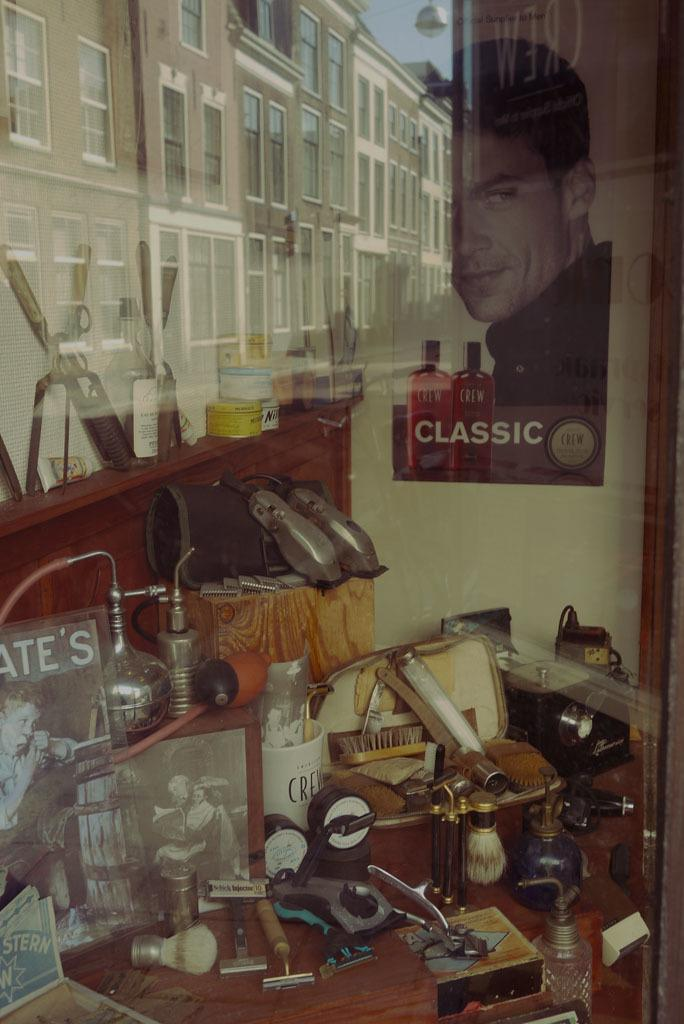<image>
Write a terse but informative summary of the picture. The display has shaving equipment and there is a Crew Classic poster on the wall. 